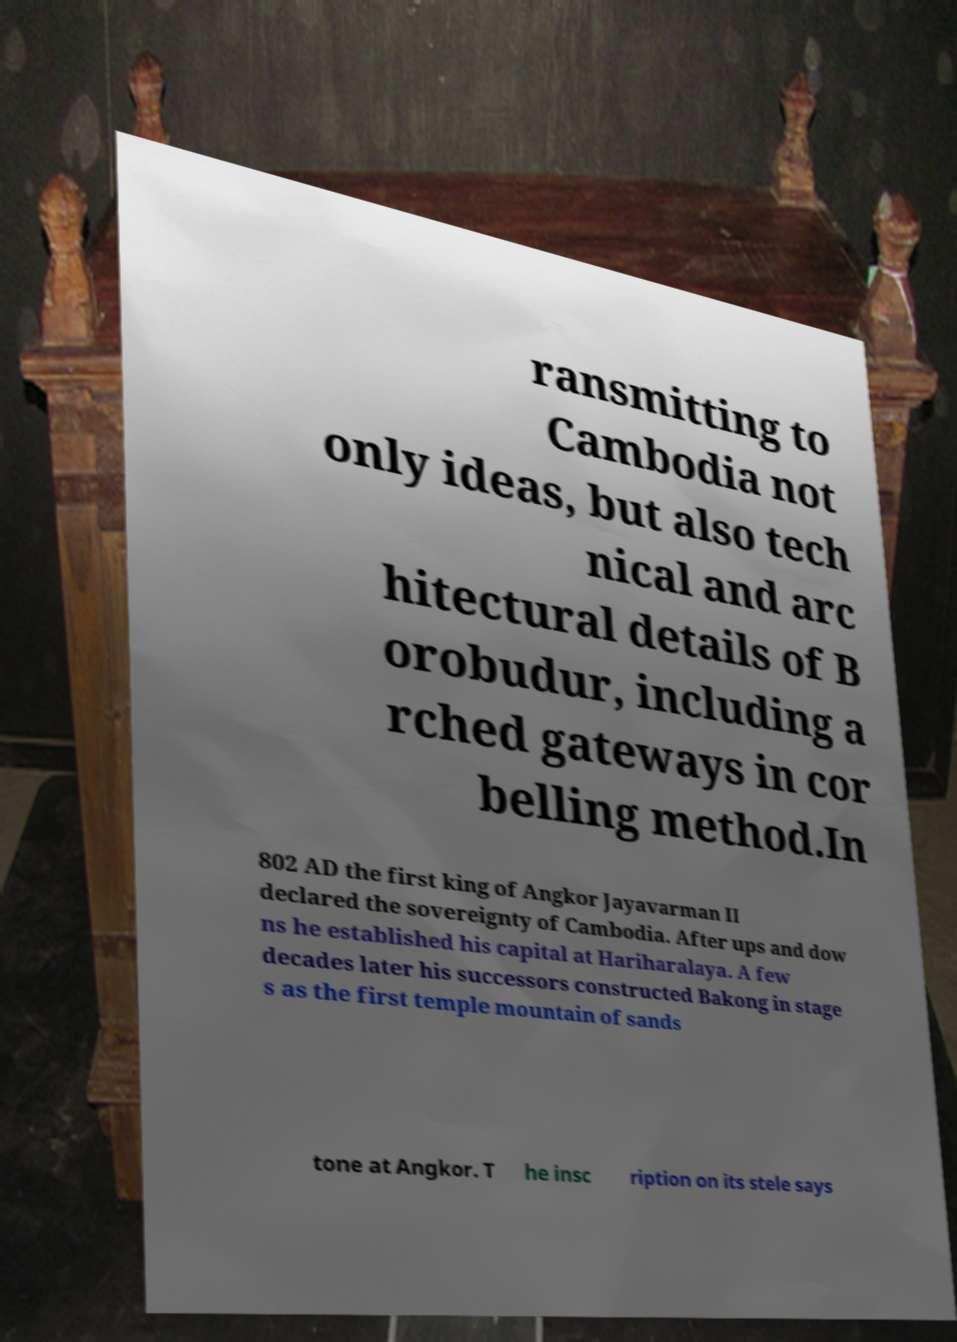Please read and relay the text visible in this image. What does it say? ransmitting to Cambodia not only ideas, but also tech nical and arc hitectural details of B orobudur, including a rched gateways in cor belling method.In 802 AD the first king of Angkor Jayavarman II declared the sovereignty of Cambodia. After ups and dow ns he established his capital at Hariharalaya. A few decades later his successors constructed Bakong in stage s as the first temple mountain of sands tone at Angkor. T he insc ription on its stele says 